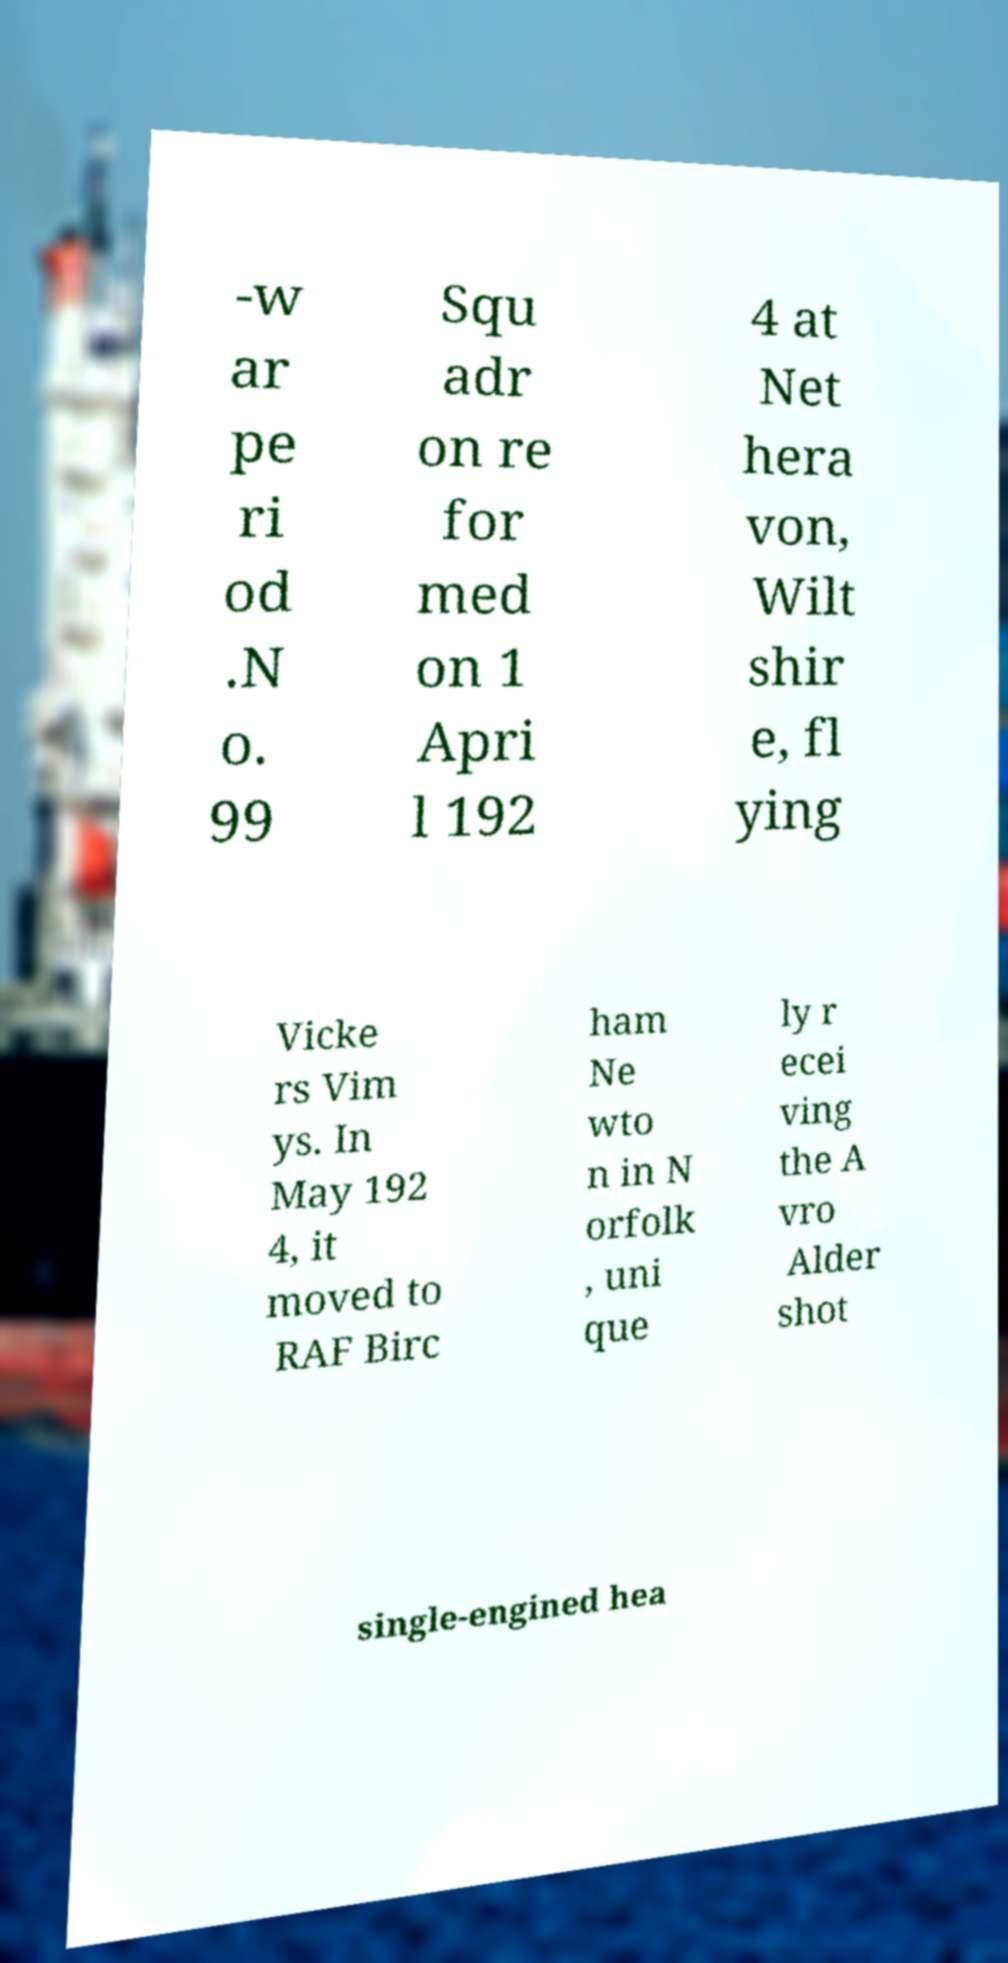Please read and relay the text visible in this image. What does it say? -w ar pe ri od .N o. 99 Squ adr on re for med on 1 Apri l 192 4 at Net hera von, Wilt shir e, fl ying Vicke rs Vim ys. In May 192 4, it moved to RAF Birc ham Ne wto n in N orfolk , uni que ly r ecei ving the A vro Alder shot single-engined hea 